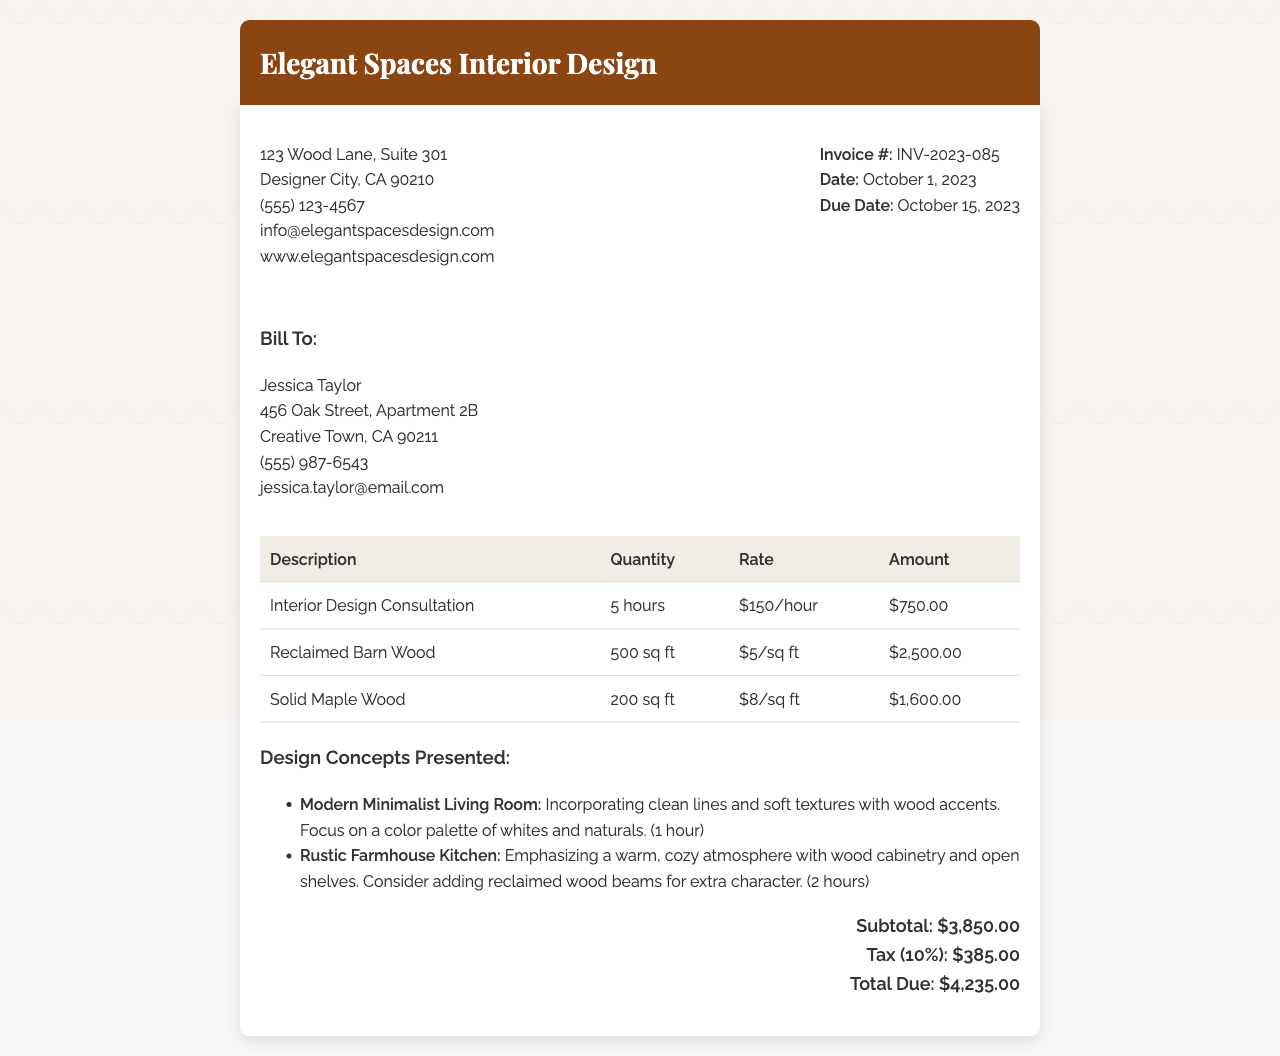What is the invoice number? The invoice number is listed in the document under the invoice details section.
Answer: INV-2023-085 What is the total amount due? The total amount due is calculated at the end of the invoice, reflecting all charges and taxes.
Answer: $4,235.00 How many hours were spent on the interior design consultation? The total hours spent on the consultation are detailed in the itemized section of the document.
Answer: 5 hours What type of wood was discussed for the kitchen design? The document lists specific materials discussed in relation to the design concepts, including the type of wood.
Answer: Reclaimed Barn Wood How much is charged per square foot for solid maple wood? The price per square foot for each material is provided in the table of the invoice.
Answer: $8/sq ft What design concept was presented that emphasizes warmth and coziness? The reasoning involves matching the description of the design concepts presented to the type of atmosphere desired.
Answer: Rustic Farmhouse Kitchen What is the subtotal before tax? The subtotal can be found by adding all the amounts before taxes are applied.
Answer: $3,850.00 